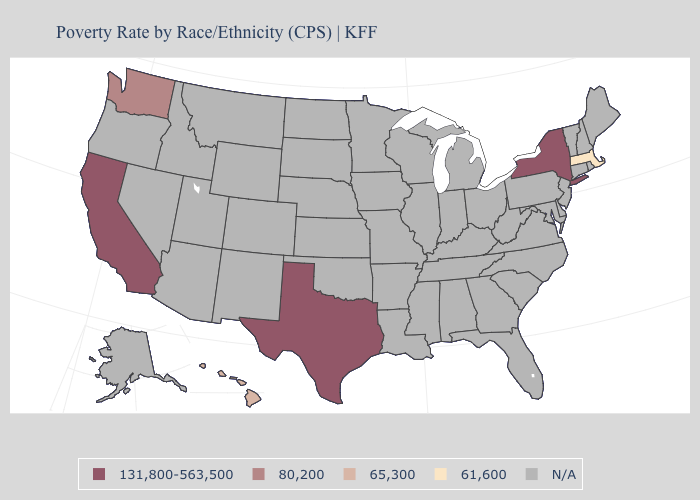Does the first symbol in the legend represent the smallest category?
Quick response, please. No. Name the states that have a value in the range N/A?
Be succinct. Alabama, Alaska, Arizona, Arkansas, Colorado, Connecticut, Delaware, Florida, Georgia, Idaho, Illinois, Indiana, Iowa, Kansas, Kentucky, Louisiana, Maine, Maryland, Michigan, Minnesota, Mississippi, Missouri, Montana, Nebraska, Nevada, New Hampshire, New Jersey, New Mexico, North Carolina, North Dakota, Ohio, Oklahoma, Oregon, Pennsylvania, Rhode Island, South Carolina, South Dakota, Tennessee, Utah, Vermont, Virginia, West Virginia, Wisconsin, Wyoming. Name the states that have a value in the range N/A?
Concise answer only. Alabama, Alaska, Arizona, Arkansas, Colorado, Connecticut, Delaware, Florida, Georgia, Idaho, Illinois, Indiana, Iowa, Kansas, Kentucky, Louisiana, Maine, Maryland, Michigan, Minnesota, Mississippi, Missouri, Montana, Nebraska, Nevada, New Hampshire, New Jersey, New Mexico, North Carolina, North Dakota, Ohio, Oklahoma, Oregon, Pennsylvania, Rhode Island, South Carolina, South Dakota, Tennessee, Utah, Vermont, Virginia, West Virginia, Wisconsin, Wyoming. Name the states that have a value in the range 61,600?
Concise answer only. Massachusetts. Does Hawaii have the lowest value in the West?
Quick response, please. Yes. Name the states that have a value in the range 65,300?
Concise answer only. Hawaii. What is the value of Wyoming?
Answer briefly. N/A. Name the states that have a value in the range 65,300?
Quick response, please. Hawaii. Name the states that have a value in the range 131,800-563,500?
Be succinct. California, New York, Texas. What is the value of Oregon?
Write a very short answer. N/A. How many symbols are there in the legend?
Quick response, please. 5. Name the states that have a value in the range 80,200?
Write a very short answer. Washington. 